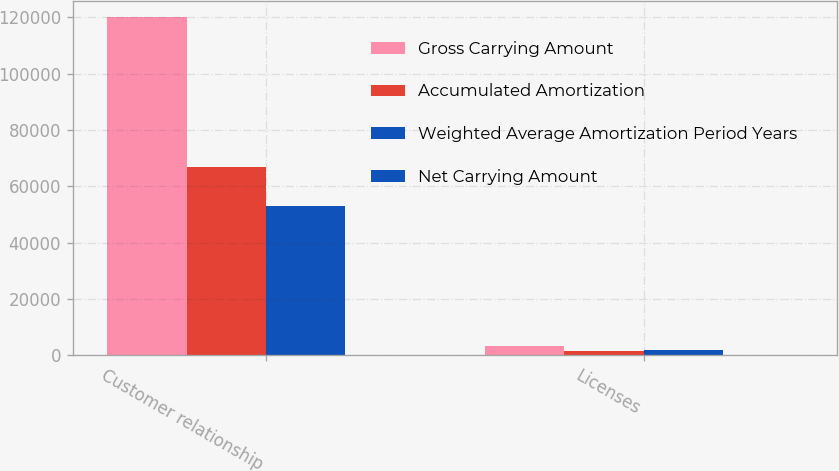<chart> <loc_0><loc_0><loc_500><loc_500><stacked_bar_chart><ecel><fcel>Customer relationship<fcel>Licenses<nl><fcel>Gross Carrying Amount<fcel>120000<fcel>3368<nl><fcel>Accumulated Amortization<fcel>66866<fcel>1601<nl><fcel>Weighted Average Amortization Period Years<fcel>53134<fcel>1767<nl><fcel>Net Carrying Amount<fcel>6<fcel>5.6<nl></chart> 